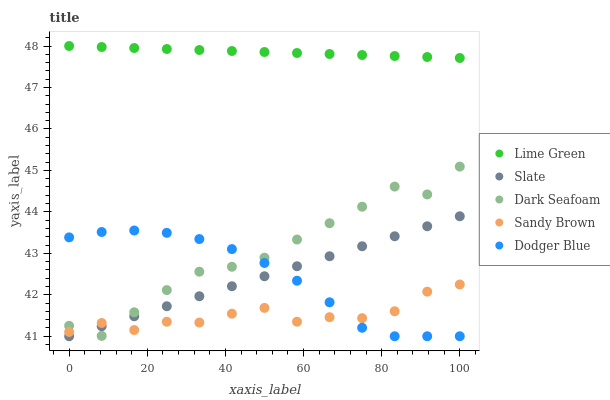Does Sandy Brown have the minimum area under the curve?
Answer yes or no. Yes. Does Lime Green have the maximum area under the curve?
Answer yes or no. Yes. Does Slate have the minimum area under the curve?
Answer yes or no. No. Does Slate have the maximum area under the curve?
Answer yes or no. No. Is Lime Green the smoothest?
Answer yes or no. Yes. Is Dark Seafoam the roughest?
Answer yes or no. Yes. Is Slate the smoothest?
Answer yes or no. No. Is Slate the roughest?
Answer yes or no. No. Does Slate have the lowest value?
Answer yes or no. Yes. Does Lime Green have the lowest value?
Answer yes or no. No. Does Lime Green have the highest value?
Answer yes or no. Yes. Does Slate have the highest value?
Answer yes or no. No. Is Sandy Brown less than Lime Green?
Answer yes or no. Yes. Is Lime Green greater than Sandy Brown?
Answer yes or no. Yes. Does Dodger Blue intersect Sandy Brown?
Answer yes or no. Yes. Is Dodger Blue less than Sandy Brown?
Answer yes or no. No. Is Dodger Blue greater than Sandy Brown?
Answer yes or no. No. Does Sandy Brown intersect Lime Green?
Answer yes or no. No. 